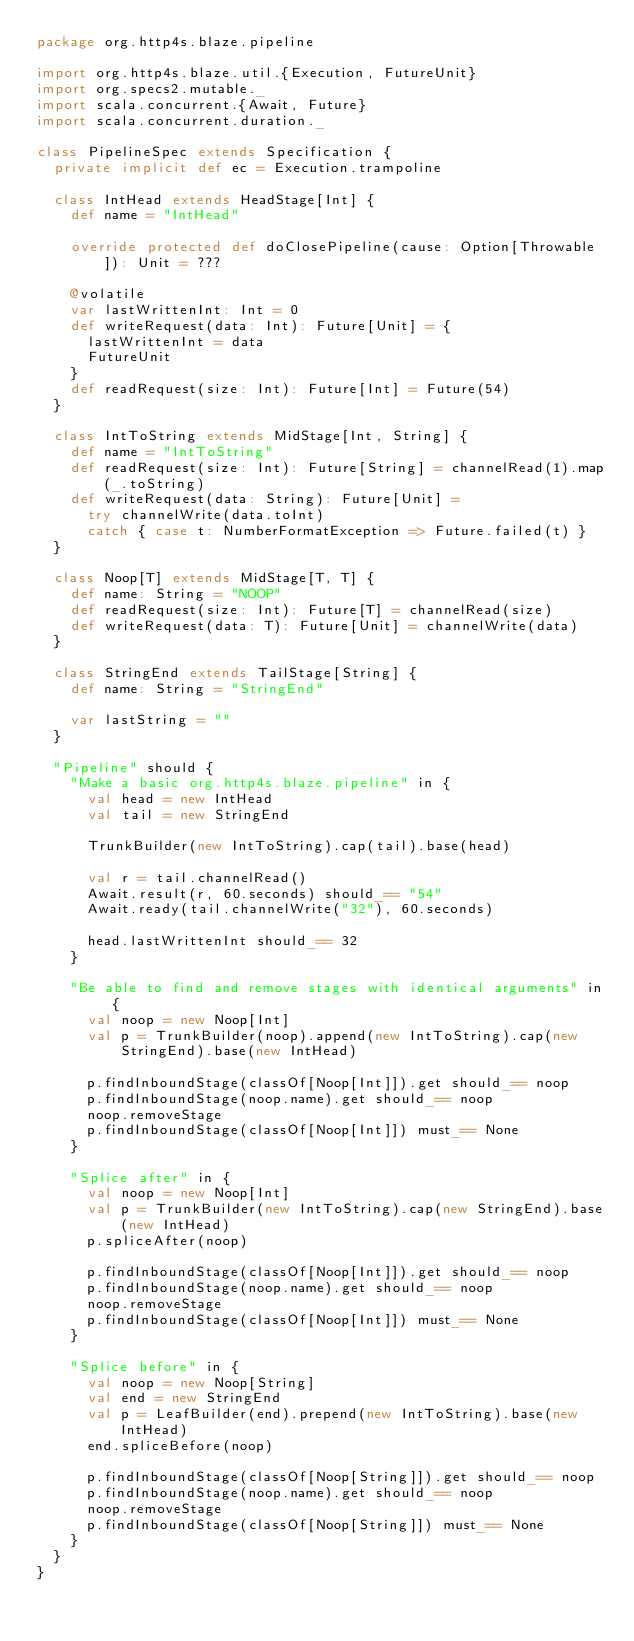<code> <loc_0><loc_0><loc_500><loc_500><_Scala_>package org.http4s.blaze.pipeline

import org.http4s.blaze.util.{Execution, FutureUnit}
import org.specs2.mutable._
import scala.concurrent.{Await, Future}
import scala.concurrent.duration._

class PipelineSpec extends Specification {
  private implicit def ec = Execution.trampoline

  class IntHead extends HeadStage[Int] {
    def name = "IntHead"

    override protected def doClosePipeline(cause: Option[Throwable]): Unit = ???

    @volatile
    var lastWrittenInt: Int = 0
    def writeRequest(data: Int): Future[Unit] = {
      lastWrittenInt = data
      FutureUnit
    }
    def readRequest(size: Int): Future[Int] = Future(54)
  }

  class IntToString extends MidStage[Int, String] {
    def name = "IntToString"
    def readRequest(size: Int): Future[String] = channelRead(1).map(_.toString)
    def writeRequest(data: String): Future[Unit] =
      try channelWrite(data.toInt)
      catch { case t: NumberFormatException => Future.failed(t) }
  }

  class Noop[T] extends MidStage[T, T] {
    def name: String = "NOOP"
    def readRequest(size: Int): Future[T] = channelRead(size)
    def writeRequest(data: T): Future[Unit] = channelWrite(data)
  }

  class StringEnd extends TailStage[String] {
    def name: String = "StringEnd"

    var lastString = ""
  }

  "Pipeline" should {
    "Make a basic org.http4s.blaze.pipeline" in {
      val head = new IntHead
      val tail = new StringEnd

      TrunkBuilder(new IntToString).cap(tail).base(head)

      val r = tail.channelRead()
      Await.result(r, 60.seconds) should_== "54"
      Await.ready(tail.channelWrite("32"), 60.seconds)

      head.lastWrittenInt should_== 32
    }

    "Be able to find and remove stages with identical arguments" in {
      val noop = new Noop[Int]
      val p = TrunkBuilder(noop).append(new IntToString).cap(new StringEnd).base(new IntHead)

      p.findInboundStage(classOf[Noop[Int]]).get should_== noop
      p.findInboundStage(noop.name).get should_== noop
      noop.removeStage
      p.findInboundStage(classOf[Noop[Int]]) must_== None
    }

    "Splice after" in {
      val noop = new Noop[Int]
      val p = TrunkBuilder(new IntToString).cap(new StringEnd).base(new IntHead)
      p.spliceAfter(noop)

      p.findInboundStage(classOf[Noop[Int]]).get should_== noop
      p.findInboundStage(noop.name).get should_== noop
      noop.removeStage
      p.findInboundStage(classOf[Noop[Int]]) must_== None
    }

    "Splice before" in {
      val noop = new Noop[String]
      val end = new StringEnd
      val p = LeafBuilder(end).prepend(new IntToString).base(new IntHead)
      end.spliceBefore(noop)

      p.findInboundStage(classOf[Noop[String]]).get should_== noop
      p.findInboundStage(noop.name).get should_== noop
      noop.removeStage
      p.findInboundStage(classOf[Noop[String]]) must_== None
    }
  }
}
</code> 